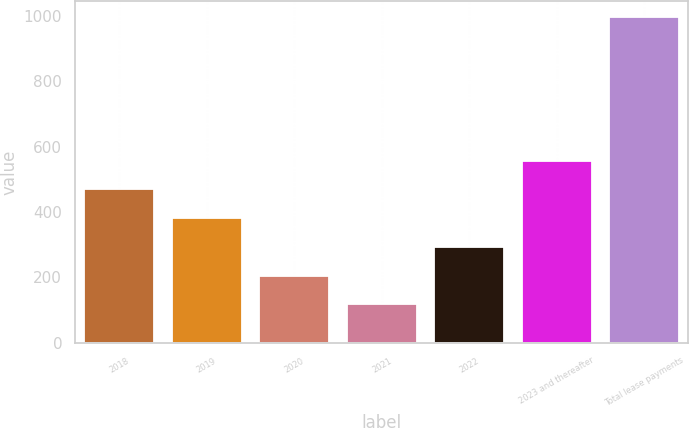Convert chart. <chart><loc_0><loc_0><loc_500><loc_500><bar_chart><fcel>2018<fcel>2019<fcel>2020<fcel>2021<fcel>2022<fcel>2023 and thereafter<fcel>Total lease payments<nl><fcel>469.2<fcel>381.4<fcel>205.8<fcel>118<fcel>293.6<fcel>557<fcel>996<nl></chart> 